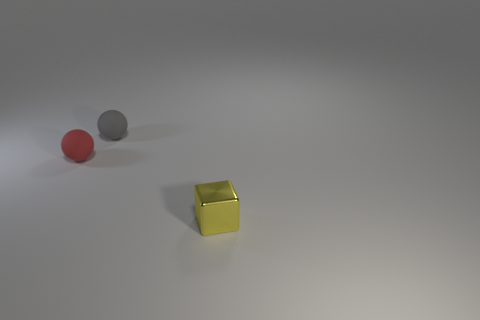Is there another matte ball of the same size as the gray ball?
Make the answer very short. Yes. There is a object on the right side of the gray sphere; does it have the same shape as the small gray matte thing?
Make the answer very short. No. What material is the small object in front of the red matte object?
Your answer should be very brief. Metal. There is a rubber object in front of the small rubber ball that is right of the red thing; what is its shape?
Make the answer very short. Sphere. Is the shape of the red thing the same as the tiny matte thing that is behind the red sphere?
Give a very brief answer. Yes. What number of tiny red rubber objects are in front of the rubber object behind the tiny red rubber object?
Give a very brief answer. 1. What material is the other thing that is the same shape as the tiny red rubber object?
Make the answer very short. Rubber. What number of gray objects are blocks or matte objects?
Make the answer very short. 1. Is there any other thing that has the same color as the small block?
Your response must be concise. No. There is a ball that is in front of the small sphere on the right side of the small red rubber sphere; what is its color?
Offer a very short reply. Red. 